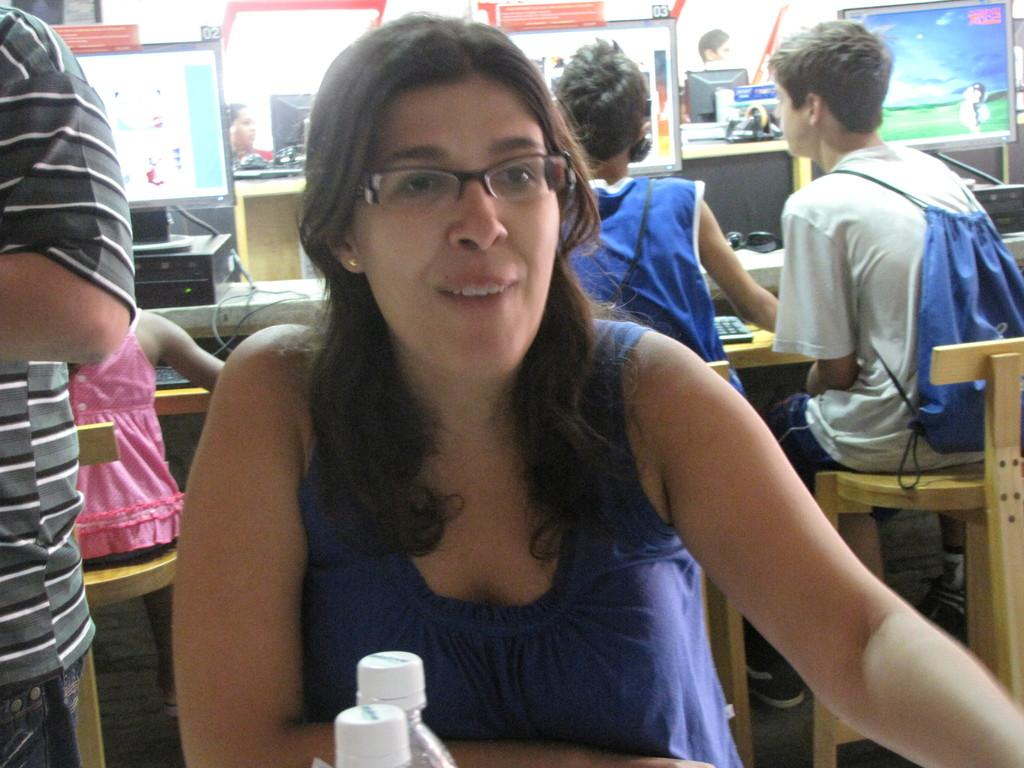What are the persons in the image doing? The persons in the image are sitting on chairs. What electronic devices can be seen in the image? There are monitors and keyboards in the image. What type of furniture is present in the image? There are tables in the image. What other objects can be seen in the image? There are devices in the image. What type of vest is the writer wearing in the image? There is no writer or vest present in the image. How many bags can be seen in the image? There are no bags present in the image. 